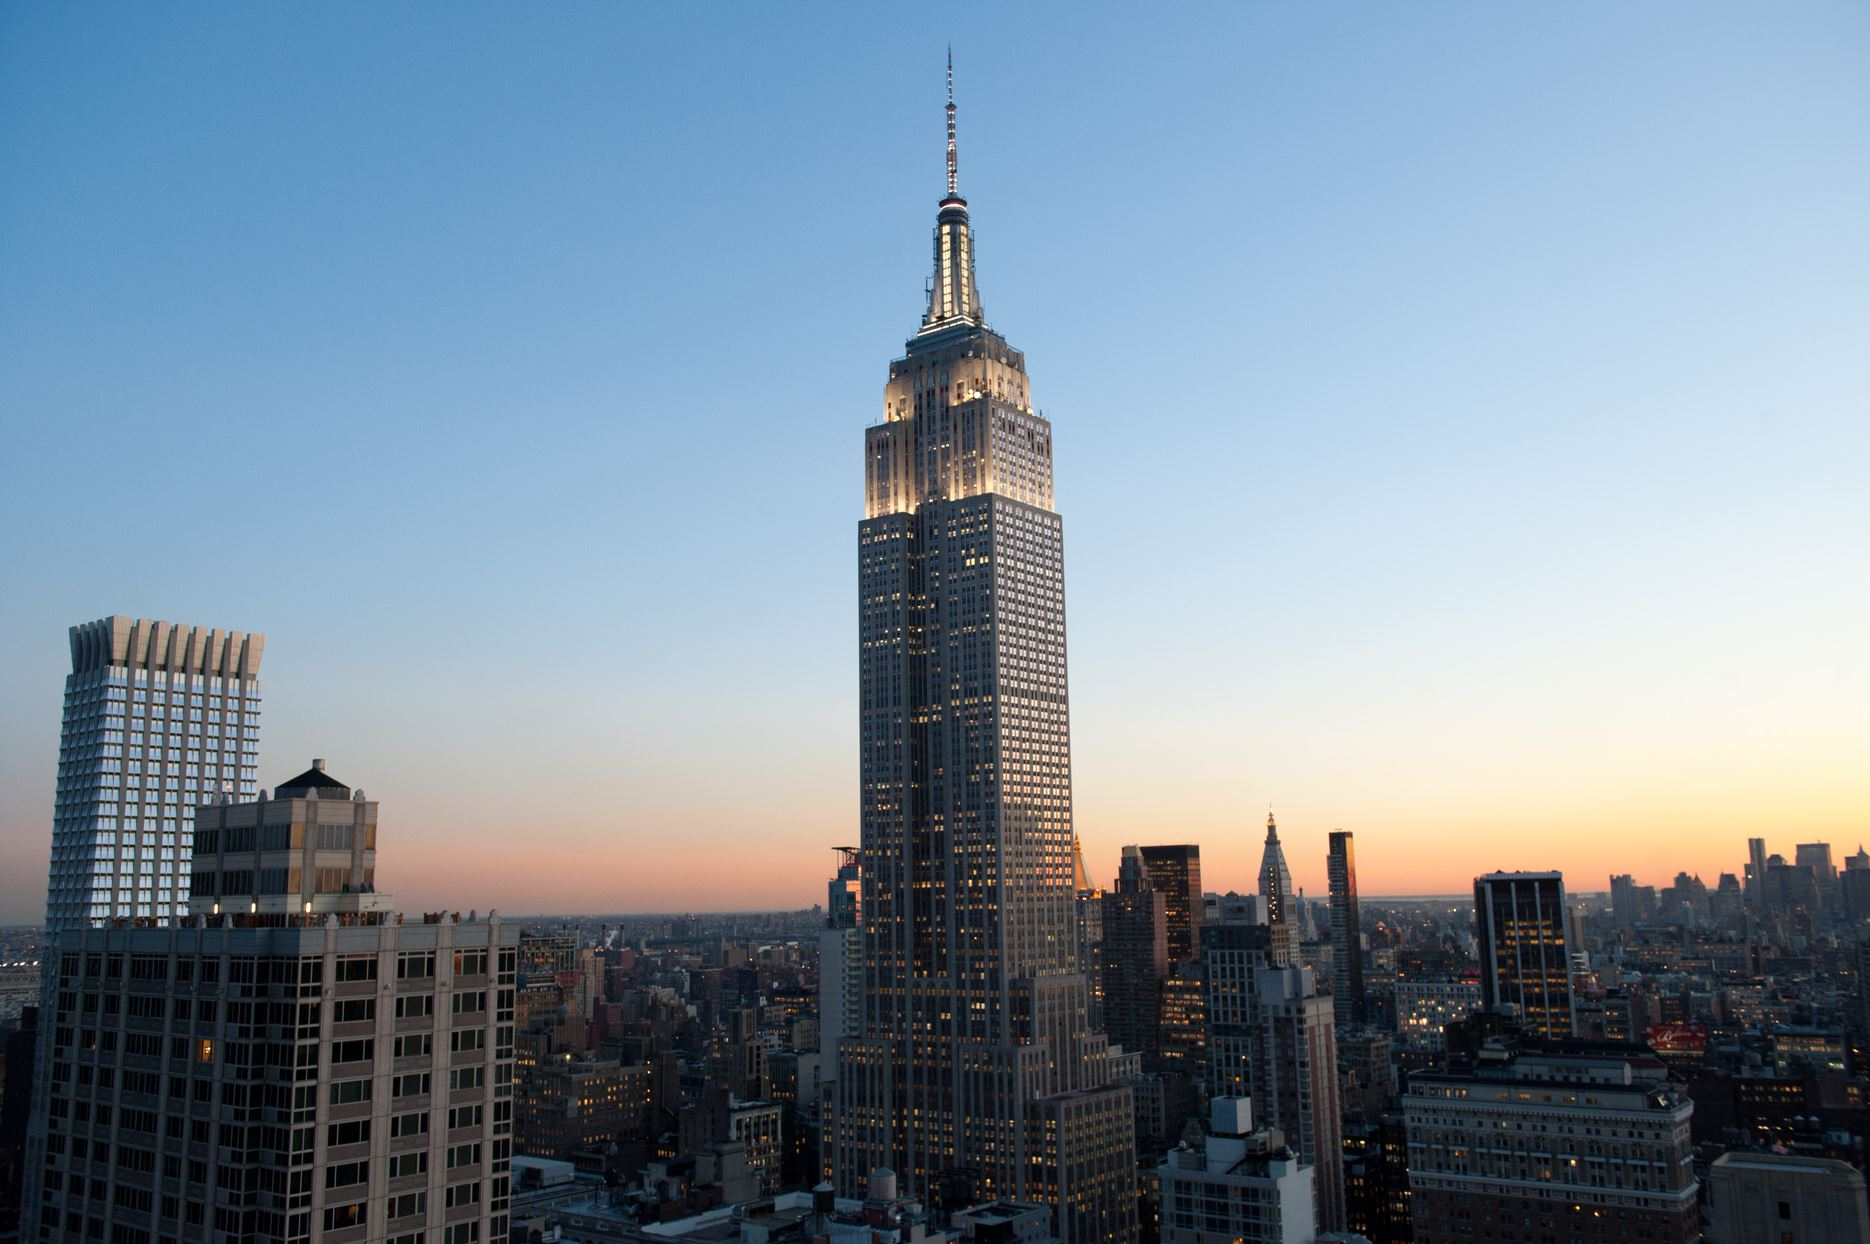Write a detailed description of the given image. The image features the Empire State Building, a notable landmark in New York City. It is prominently illuminated and stands tall against the urban landscape. The photograph is captured from a higher vantage point, offering a view that looks down upon the sprawling city. The sky above exhibits a gorgeous gradient of orange and blue shades, suggesting it is around sunset. The city below is bathed in the warm hues of the setting sun, enhancing the overall ambiance of the scene. The Empire State Building, being the tallest structure in view, dominates the skyline. The image encapsulates the essence of New York City at dusk, with the Empire State Building as the focal point amidst the glowing cityscape. 